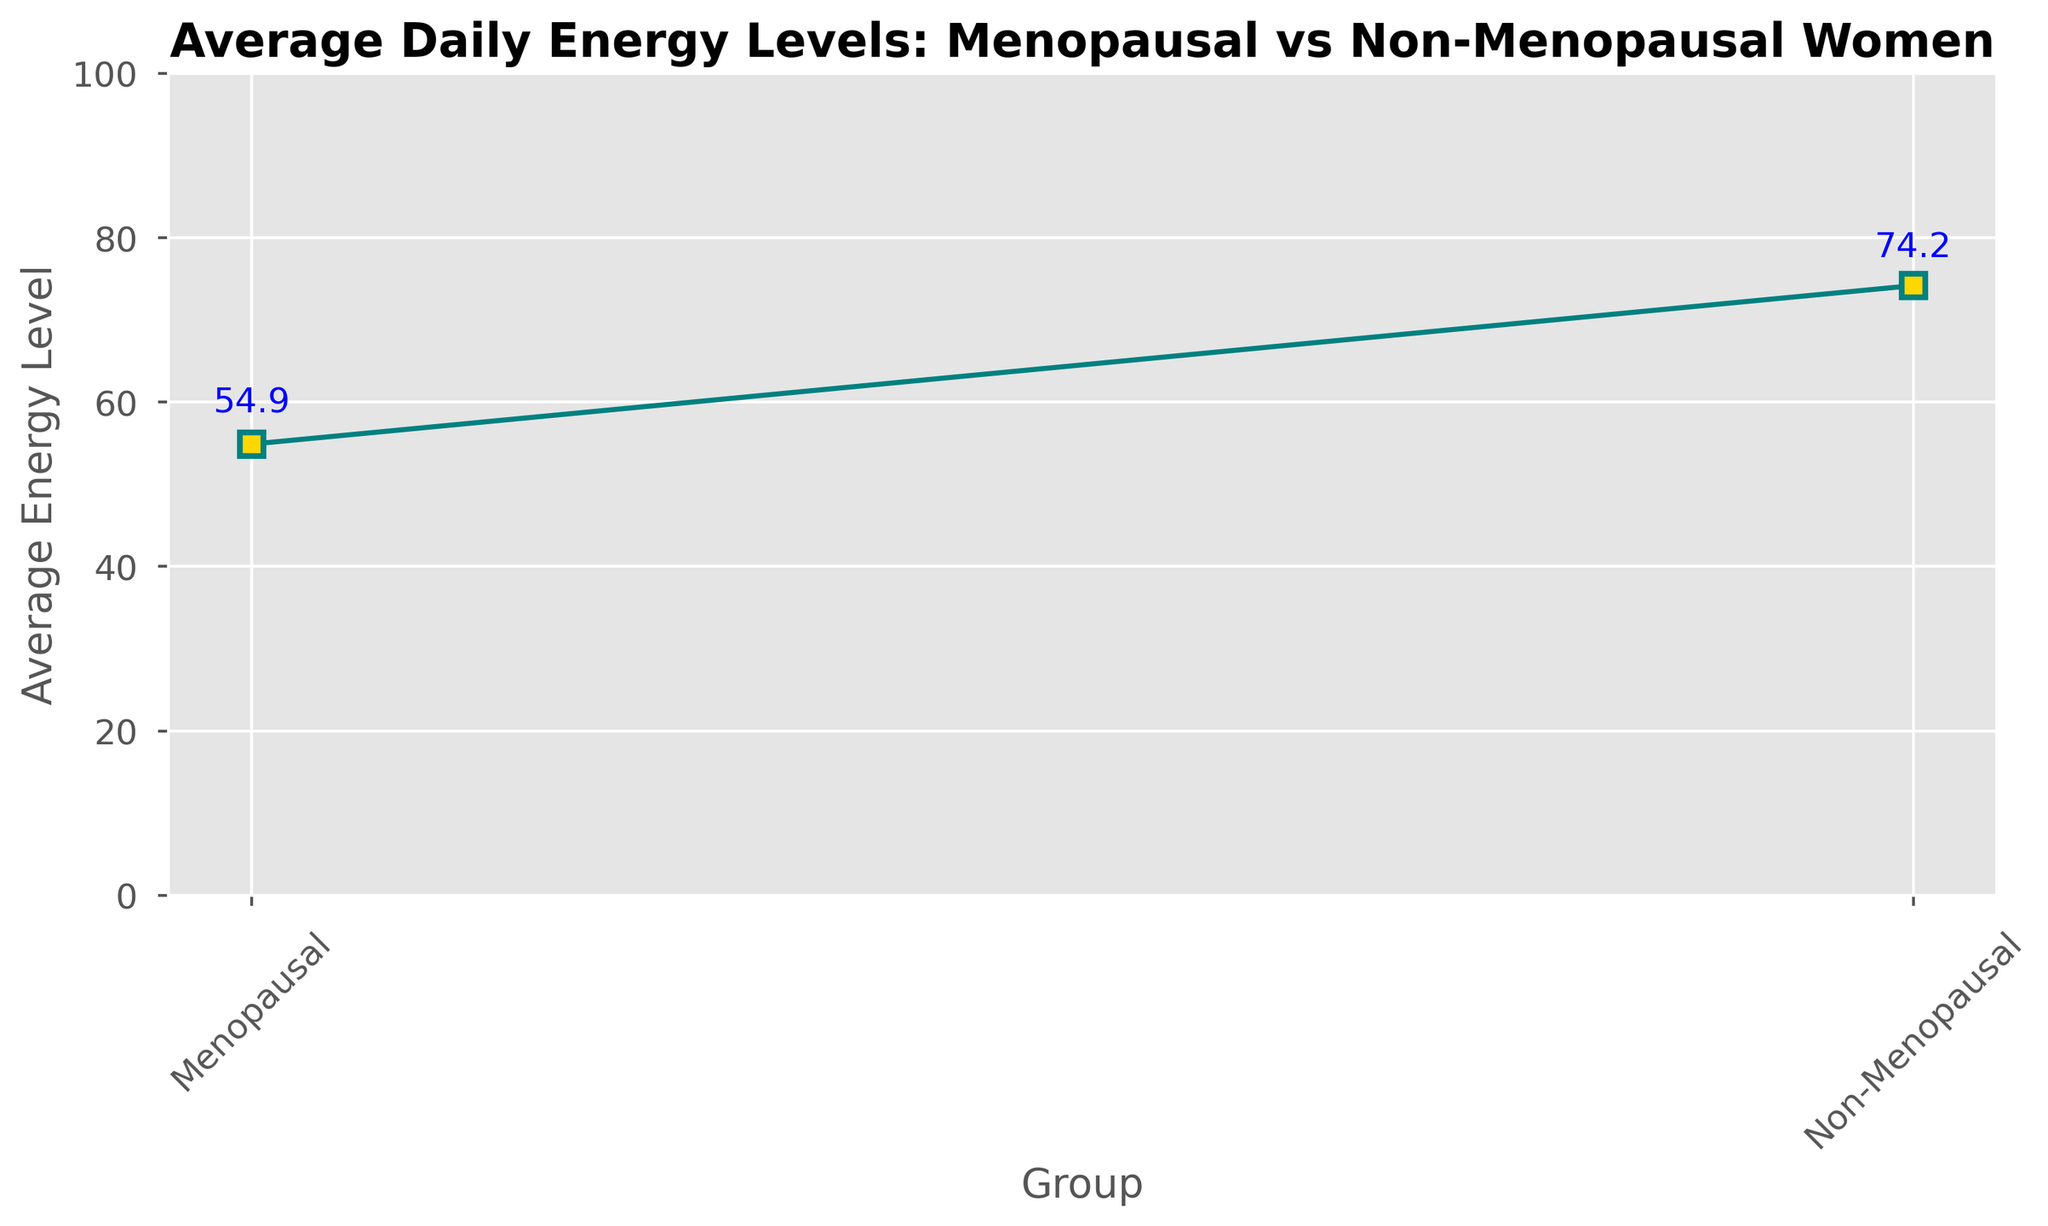What is the mean energy level for menopausal women? The chart shows Menopausal women have a mean energy level indicated next to their data point.
Answer: 54.9 What is the mean energy level for non-menopausal women? The chart shows Non-Menopausal women have a mean energy level indicated next to their data point.
Answer: 74.2 Which group shows a higher average daily energy level? Compare the mean energy levels of Menopausal and Non-Menopausal women shown on the chart.
Answer: Non-Menopausal Which group has a larger standard deviation in energy levels? Compare the error bars (indicating standard deviation) for both groups in the figure.
Answer: Menopausal By how much is the average energy level of non-menopausal women higher than that of menopausal women? Subtract the mean energy level of Menopausal women from that of Non-Menopausal women (74.2 - 54.9).
Answer: 19.3 Which group's data points have a wider spread? The wider spread of data points will be indicated by larger error bars on the chart.
Answer: Menopausal 